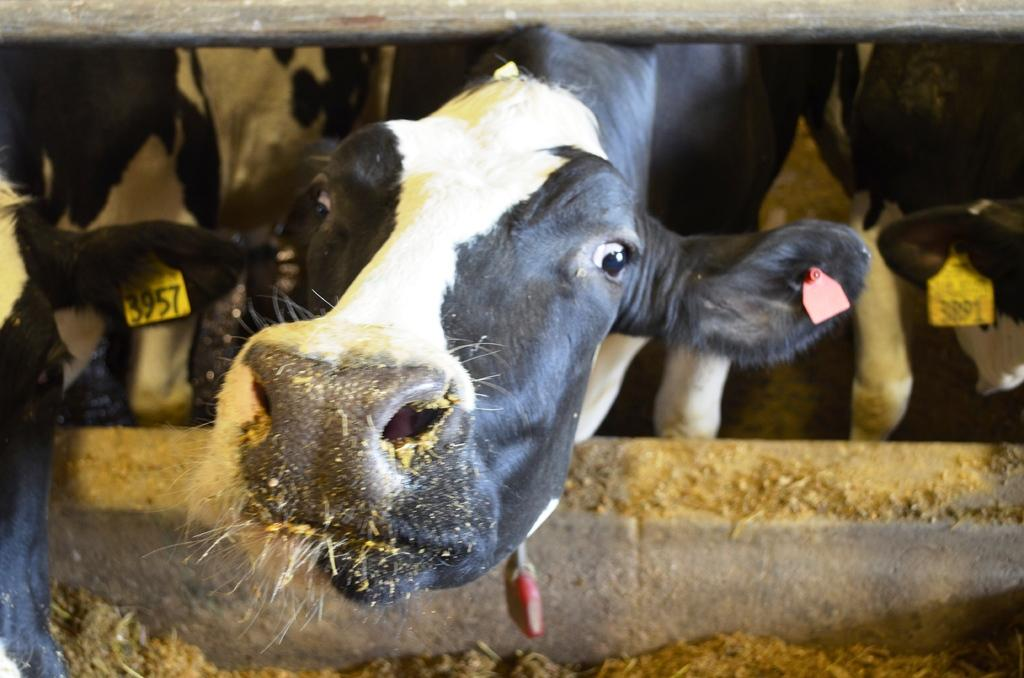What types of living organisms can be seen in the image? There are animals in the picture. How can the animals be identified in the image? The animals have tags with numbers on them. What direction are the animals moving in the image? The image does not show the animals in motion, so it is not possible to determine the direction they are moving. 